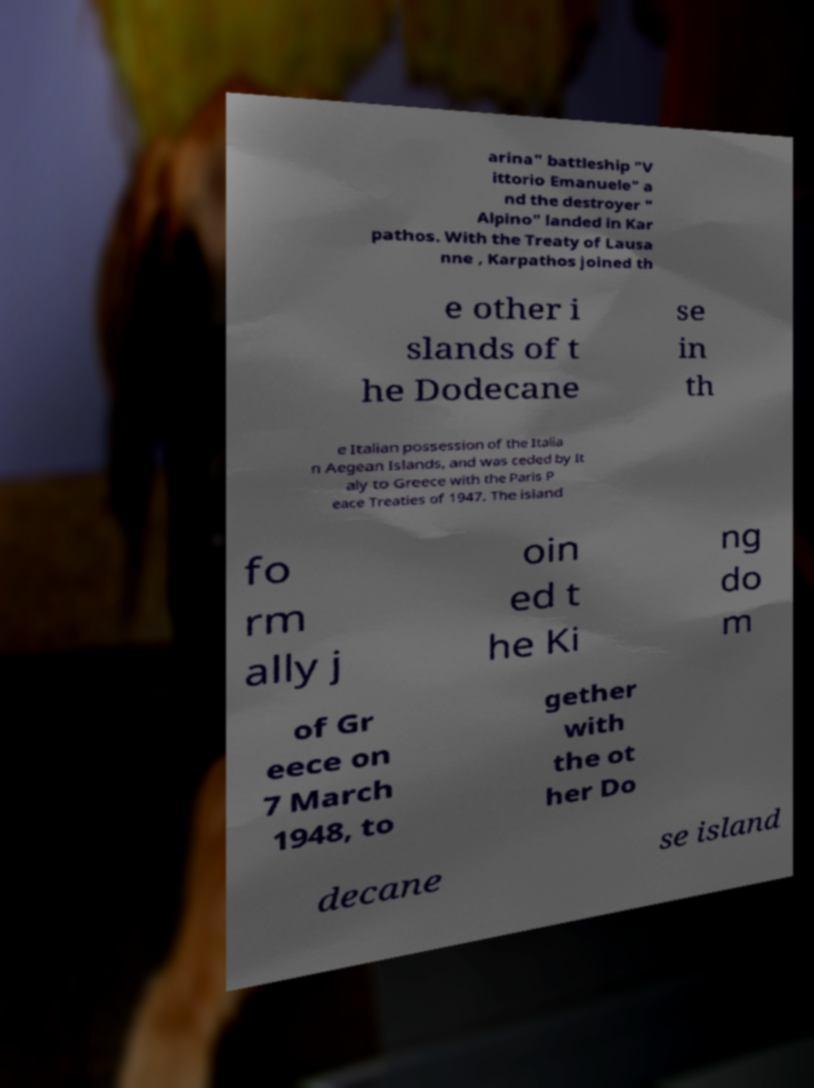Please identify and transcribe the text found in this image. arina" battleship "V ittorio Emanuele" a nd the destroyer " Alpino" landed in Kar pathos. With the Treaty of Lausa nne , Karpathos joined th e other i slands of t he Dodecane se in th e Italian possession of the Italia n Aegean Islands, and was ceded by It aly to Greece with the Paris P eace Treaties of 1947. The island fo rm ally j oin ed t he Ki ng do m of Gr eece on 7 March 1948, to gether with the ot her Do decane se island 